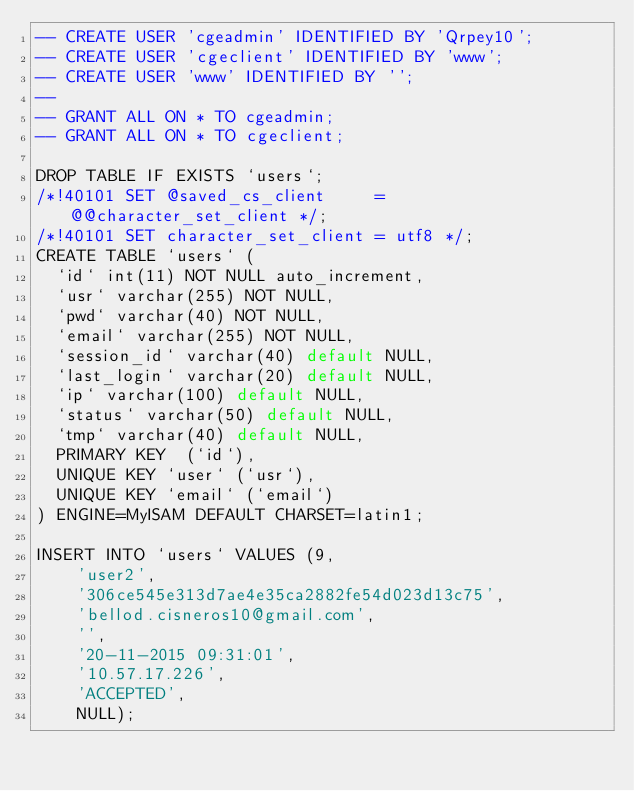Convert code to text. <code><loc_0><loc_0><loc_500><loc_500><_SQL_>-- CREATE USER 'cgeadmin' IDENTIFIED BY 'Qrpey10';
-- CREATE USER 'cgeclient' IDENTIFIED BY 'www';
-- CREATE USER 'www' IDENTIFIED BY '';
--
-- GRANT ALL ON * TO cgeadmin;
-- GRANT ALL ON * TO cgeclient;

DROP TABLE IF EXISTS `users`;
/*!40101 SET @saved_cs_client     = @@character_set_client */;
/*!40101 SET character_set_client = utf8 */;
CREATE TABLE `users` (
  `id` int(11) NOT NULL auto_increment,
  `usr` varchar(255) NOT NULL,
  `pwd` varchar(40) NOT NULL,
  `email` varchar(255) NOT NULL,
  `session_id` varchar(40) default NULL,
  `last_login` varchar(20) default NULL,
  `ip` varchar(100) default NULL,
  `status` varchar(50) default NULL,
  `tmp` varchar(40) default NULL,
  PRIMARY KEY  (`id`),
  UNIQUE KEY `user` (`usr`),
  UNIQUE KEY `email` (`email`)
) ENGINE=MyISAM DEFAULT CHARSET=latin1;

INSERT INTO `users` VALUES (9,
    'user2',
    '306ce545e313d7ae4e35ca2882fe54d023d13c75',
    'bellod.cisneros10@gmail.com',
    '',
    '20-11-2015 09:31:01',
    '10.57.17.226',
    'ACCEPTED',
    NULL);
</code> 